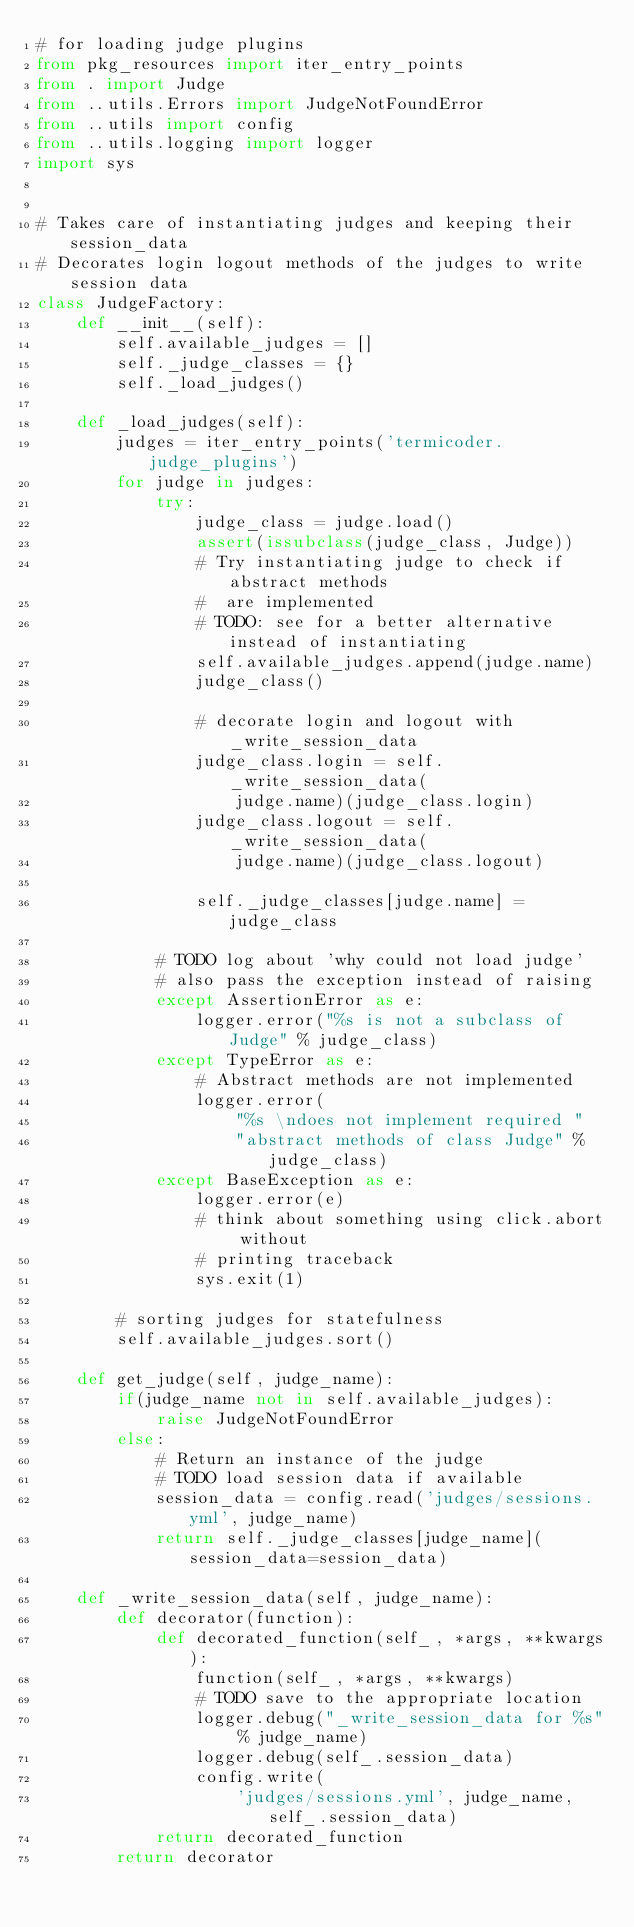<code> <loc_0><loc_0><loc_500><loc_500><_Python_># for loading judge plugins
from pkg_resources import iter_entry_points
from . import Judge
from ..utils.Errors import JudgeNotFoundError
from ..utils import config
from ..utils.logging import logger
import sys


# Takes care of instantiating judges and keeping their session_data
# Decorates login logout methods of the judges to write session data
class JudgeFactory:
    def __init__(self):
        self.available_judges = []
        self._judge_classes = {}
        self._load_judges()

    def _load_judges(self):
        judges = iter_entry_points('termicoder.judge_plugins')
        for judge in judges:
            try:
                judge_class = judge.load()
                assert(issubclass(judge_class, Judge))
                # Try instantiating judge to check if abstract methods
                #  are implemented
                # TODO: see for a better alternative instead of instantiating
                self.available_judges.append(judge.name)
                judge_class()

                # decorate login and logout with _write_session_data
                judge_class.login = self._write_session_data(
                    judge.name)(judge_class.login)
                judge_class.logout = self._write_session_data(
                    judge.name)(judge_class.logout)

                self._judge_classes[judge.name] = judge_class

            # TODO log about 'why could not load judge'
            # also pass the exception instead of raising
            except AssertionError as e:
                logger.error("%s is not a subclass of Judge" % judge_class)
            except TypeError as e:
                # Abstract methods are not implemented
                logger.error(
                    "%s \ndoes not implement required "
                    "abstract methods of class Judge" % judge_class)
            except BaseException as e:
                logger.error(e)
                # think about something using click.abort without
                # printing traceback
                sys.exit(1)

        # sorting judges for statefulness
        self.available_judges.sort()

    def get_judge(self, judge_name):
        if(judge_name not in self.available_judges):
            raise JudgeNotFoundError
        else:
            # Return an instance of the judge
            # TODO load session data if available
            session_data = config.read('judges/sessions.yml', judge_name)
            return self._judge_classes[judge_name](session_data=session_data)

    def _write_session_data(self, judge_name):
        def decorator(function):
            def decorated_function(self_, *args, **kwargs):
                function(self_, *args, **kwargs)
                # TODO save to the appropriate location
                logger.debug("_write_session_data for %s" % judge_name)
                logger.debug(self_.session_data)
                config.write(
                    'judges/sessions.yml', judge_name, self_.session_data)
            return decorated_function
        return decorator
</code> 